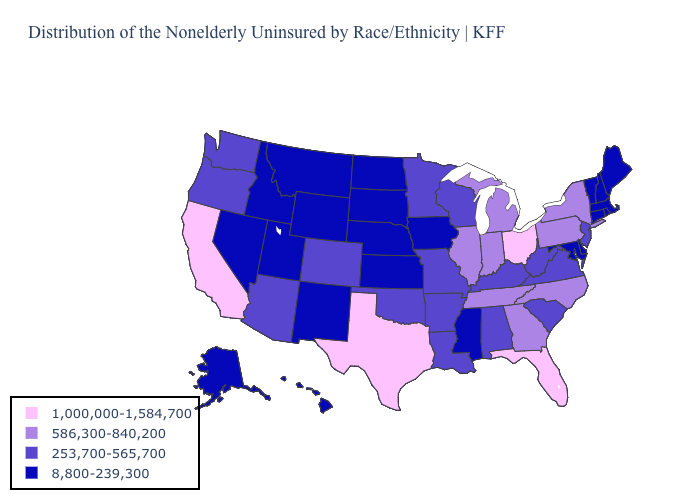What is the value of Colorado?
Keep it brief. 253,700-565,700. Which states hav the highest value in the Northeast?
Answer briefly. New York, Pennsylvania. What is the value of Mississippi?
Write a very short answer. 8,800-239,300. What is the value of Kentucky?
Give a very brief answer. 253,700-565,700. What is the value of Hawaii?
Short answer required. 8,800-239,300. Which states have the highest value in the USA?
Answer briefly. California, Florida, Ohio, Texas. What is the lowest value in the MidWest?
Keep it brief. 8,800-239,300. Name the states that have a value in the range 1,000,000-1,584,700?
Be succinct. California, Florida, Ohio, Texas. Does Massachusetts have the highest value in the USA?
Quick response, please. No. What is the value of Utah?
Concise answer only. 8,800-239,300. Name the states that have a value in the range 1,000,000-1,584,700?
Give a very brief answer. California, Florida, Ohio, Texas. Name the states that have a value in the range 8,800-239,300?
Answer briefly. Alaska, Connecticut, Delaware, Hawaii, Idaho, Iowa, Kansas, Maine, Maryland, Massachusetts, Mississippi, Montana, Nebraska, Nevada, New Hampshire, New Mexico, North Dakota, Rhode Island, South Dakota, Utah, Vermont, Wyoming. What is the lowest value in states that border Oklahoma?
Concise answer only. 8,800-239,300. Name the states that have a value in the range 8,800-239,300?
Give a very brief answer. Alaska, Connecticut, Delaware, Hawaii, Idaho, Iowa, Kansas, Maine, Maryland, Massachusetts, Mississippi, Montana, Nebraska, Nevada, New Hampshire, New Mexico, North Dakota, Rhode Island, South Dakota, Utah, Vermont, Wyoming. Which states have the lowest value in the USA?
Quick response, please. Alaska, Connecticut, Delaware, Hawaii, Idaho, Iowa, Kansas, Maine, Maryland, Massachusetts, Mississippi, Montana, Nebraska, Nevada, New Hampshire, New Mexico, North Dakota, Rhode Island, South Dakota, Utah, Vermont, Wyoming. 